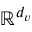<formula> <loc_0><loc_0><loc_500><loc_500>\mathbb { R } ^ { d _ { v } }</formula> 